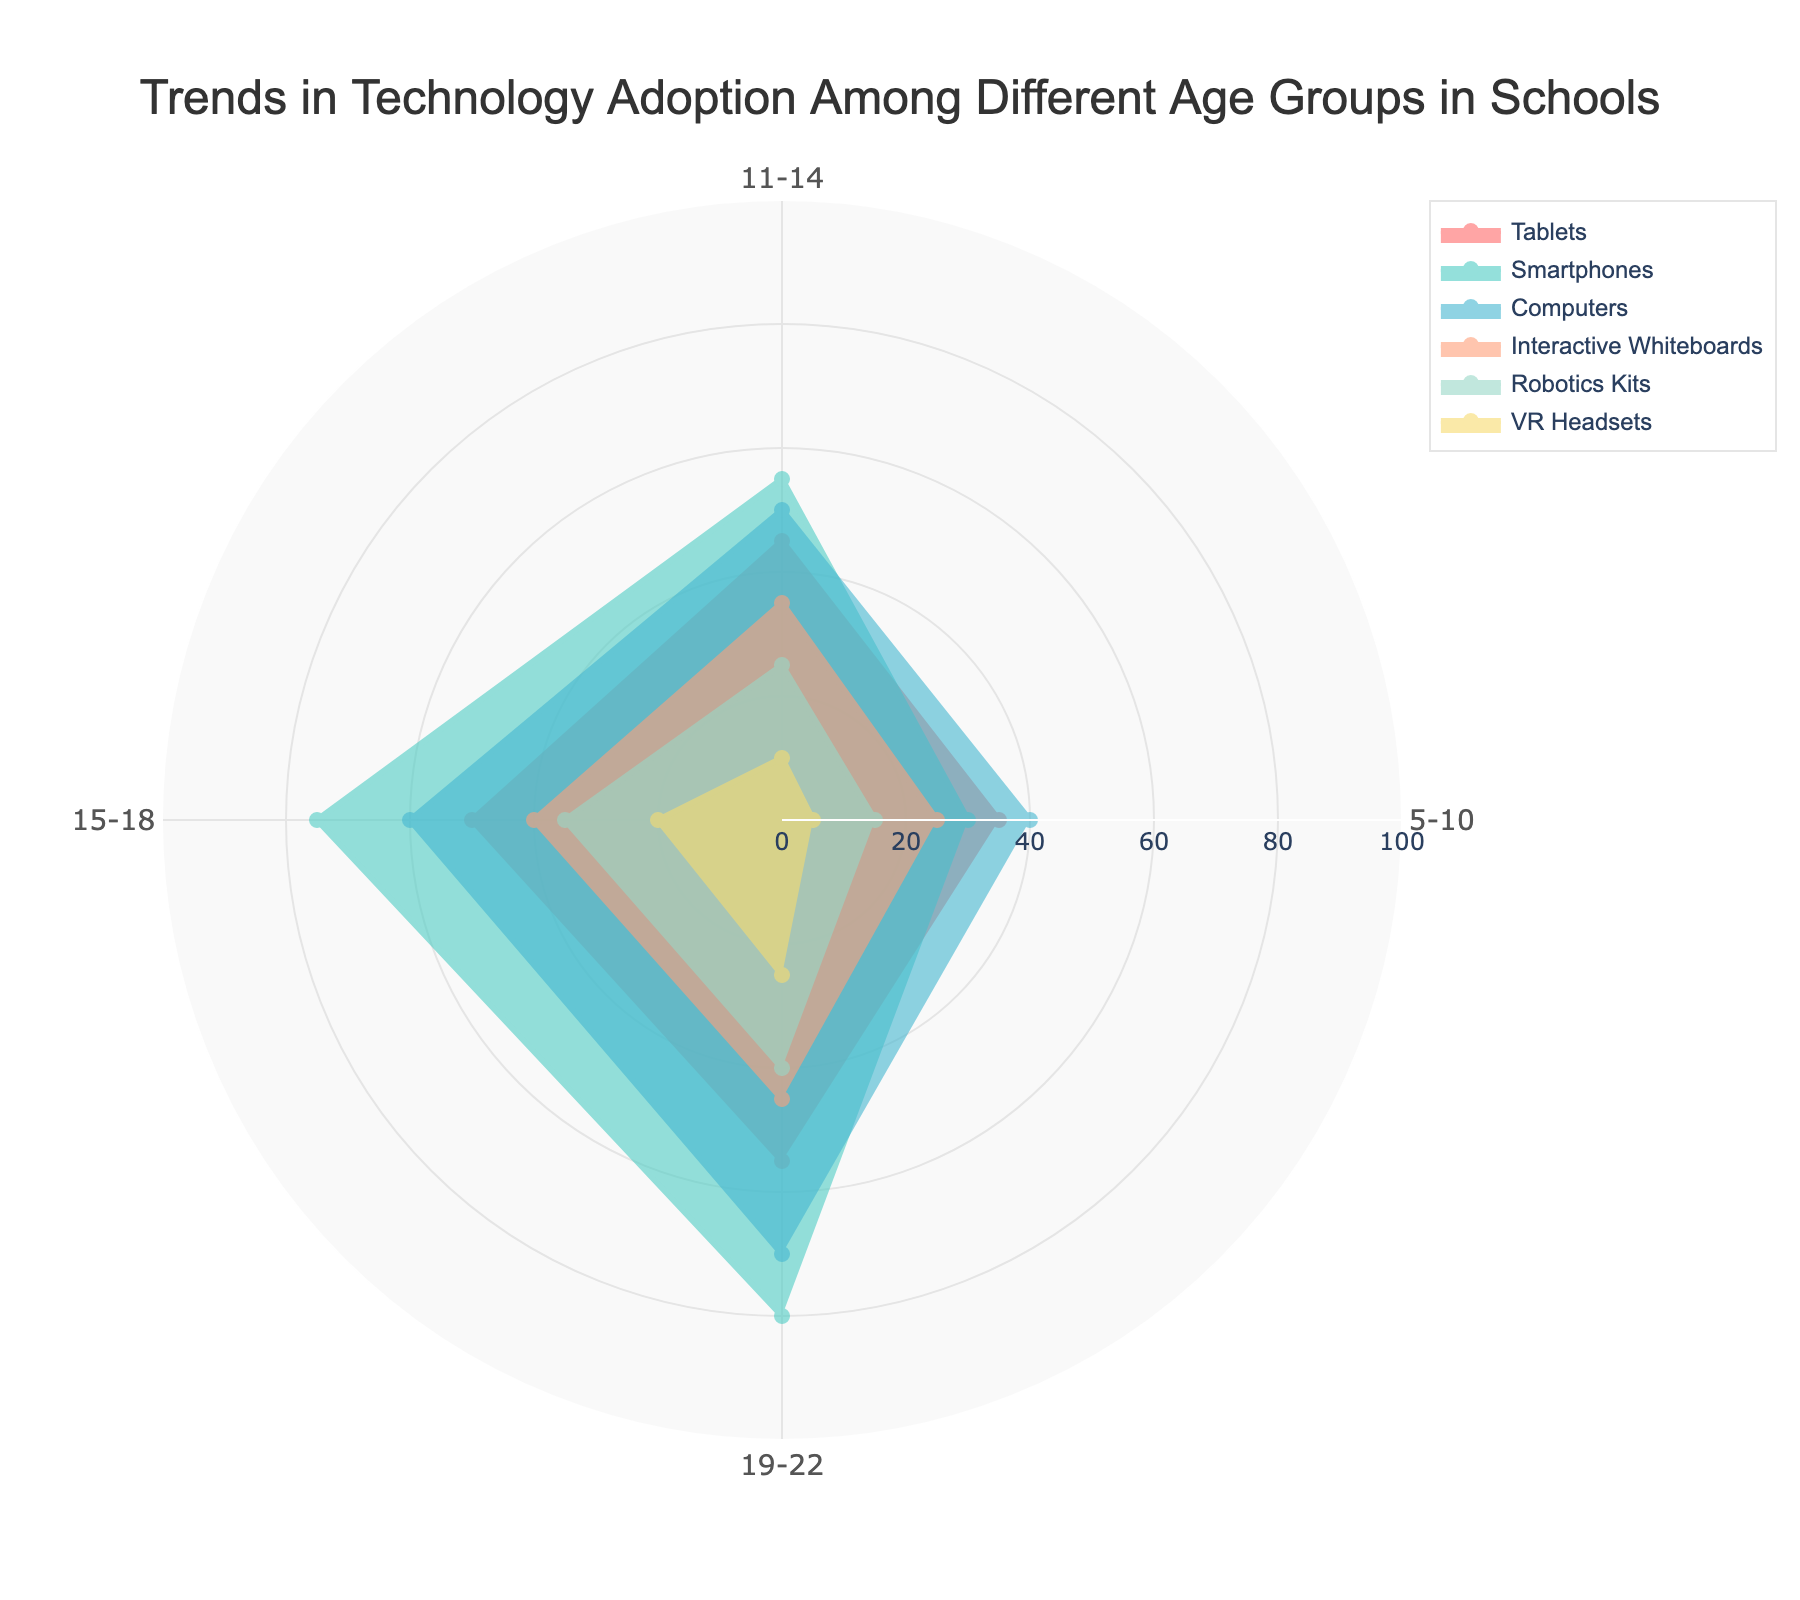what is the title of the chart? The title is usually located at the top center of the chart. It describes what the chart is about.
Answer: Trends in Technology Adoption Among Different Age Groups in Schools Which age group has the highest adoption of VR Headsets? Locate the VR Headsets series on the chart. Identify the age group with the longest radius in this series.
Answer: 19-22 What is the difference in tablet adoption between the 5-10 and 15-18 age groups? Identify the values for tablet adoption for both age groups. Subtract the smaller value (5-10) from the larger value (15-18).
Answer: 50 - 35 = 15 Which technology has the lowest adoption rate among the 11-14 age group? Look at the different technologies for the 11-14 age group and identify the one with the shortest radius (lowest value).
Answer: VR Headsets What is the total adoption percentage for Robotics Kits across all age groups? Sum the adoption percentages of Robotics Kits for each age group.
Answer: 15 + 25 + 35 + 40 = 115 Which age group has the highest adoption of total technology? For each age group, sum the adoption rates of all technologies. Compare the total values and identify the highest one.
Answer: 19-22 Compare the adoption rates of Smartphones between the 11-14 and 15-18 age groups. Which one is higher? Identify the adoption rate of Smartphones for the 11-14 age group and the 15-18 age group. Compare the two values.
Answer: 15-18 Which technology shows a consistent increase in adoption rate across all age groups? For each technology, check if the adoption rate increases from the youngest to the oldest age group without any decrease.
Answer: Computers What is the range of adoption rates for Interactive Whiteboards across all age groups? Identify the maximum and minimum adoption rates of Interactive Whiteboards among all age groups, then subtract the minimum from the maximum.
Answer: 45 - 25 = 20 